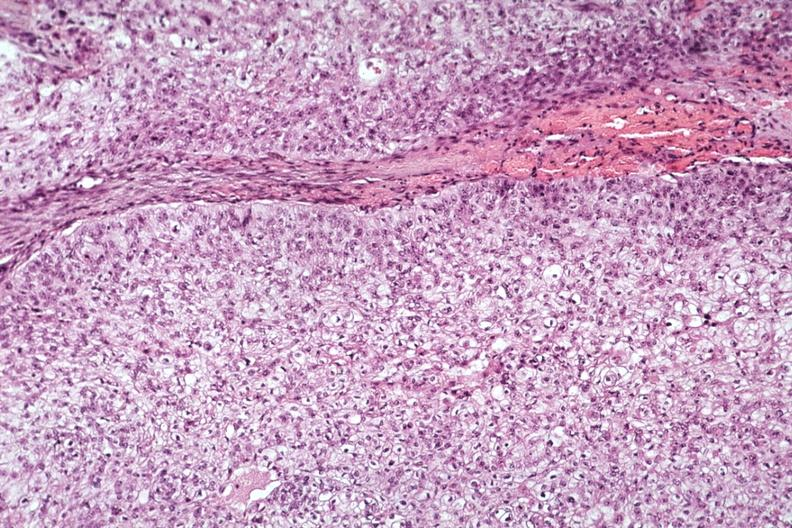does metastatic carcinoma lung show good photo of tumor cells?
Answer the question using a single word or phrase. No 